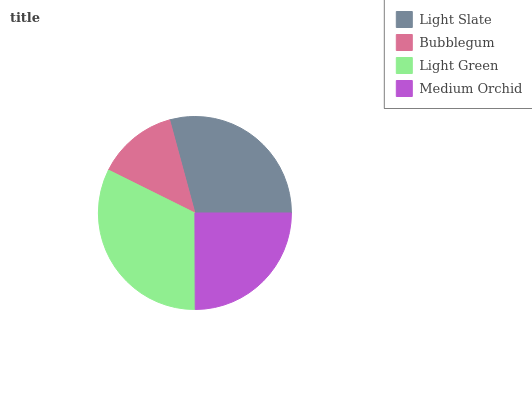Is Bubblegum the minimum?
Answer yes or no. Yes. Is Light Green the maximum?
Answer yes or no. Yes. Is Light Green the minimum?
Answer yes or no. No. Is Bubblegum the maximum?
Answer yes or no. No. Is Light Green greater than Bubblegum?
Answer yes or no. Yes. Is Bubblegum less than Light Green?
Answer yes or no. Yes. Is Bubblegum greater than Light Green?
Answer yes or no. No. Is Light Green less than Bubblegum?
Answer yes or no. No. Is Light Slate the high median?
Answer yes or no. Yes. Is Medium Orchid the low median?
Answer yes or no. Yes. Is Light Green the high median?
Answer yes or no. No. Is Bubblegum the low median?
Answer yes or no. No. 